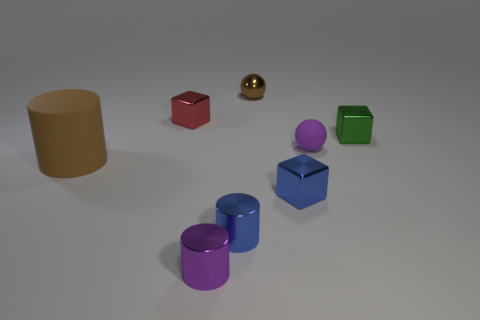Subtract 1 cylinders. How many cylinders are left? 2 Subtract all shiny cylinders. How many cylinders are left? 1 Add 1 gray shiny things. How many objects exist? 9 Subtract all yellow cylinders. Subtract all purple balls. How many cylinders are left? 3 Subtract all cylinders. How many objects are left? 5 Add 3 purple objects. How many purple objects exist? 5 Subtract 0 gray spheres. How many objects are left? 8 Subtract all tiny purple matte things. Subtract all large rubber things. How many objects are left? 6 Add 8 tiny matte objects. How many tiny matte objects are left? 9 